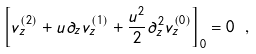Convert formula to latex. <formula><loc_0><loc_0><loc_500><loc_500>\left [ v _ { z } ^ { ( 2 ) } + u \partial _ { z } v _ { z } ^ { ( 1 ) } + \frac { u ^ { 2 } } { 2 } \partial ^ { 2 } _ { z } v _ { z } ^ { ( 0 ) } \right ] _ { 0 } = 0 \ ,</formula> 